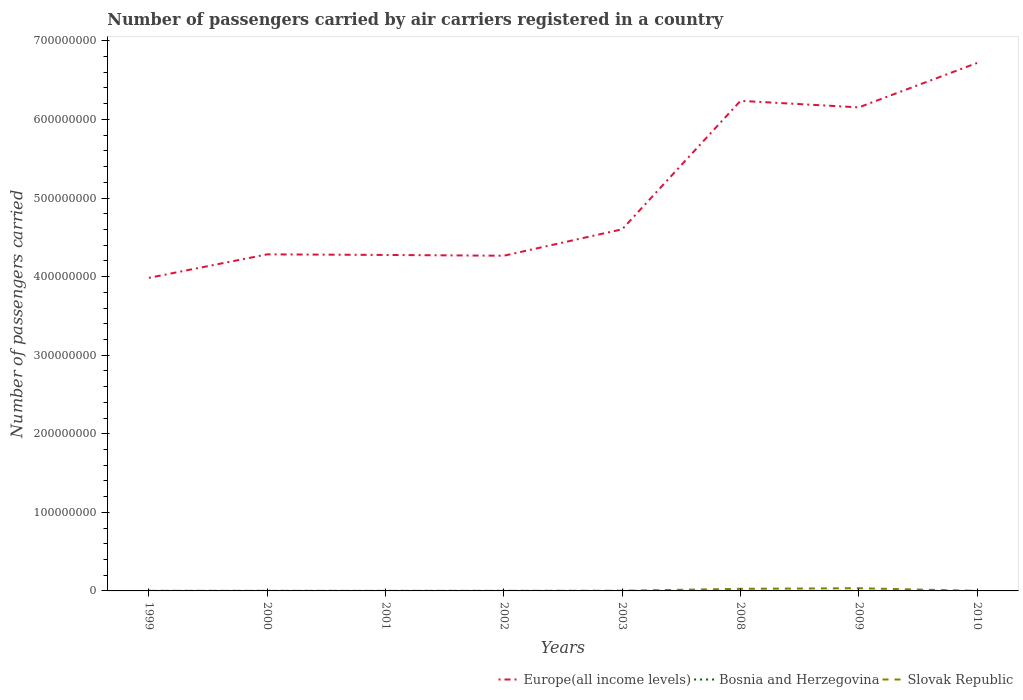How many different coloured lines are there?
Ensure brevity in your answer.  3. Across all years, what is the maximum number of passengers carried by air carriers in Europe(all income levels)?
Your response must be concise. 3.98e+08. What is the total number of passengers carried by air carriers in Bosnia and Herzegovina in the graph?
Give a very brief answer. 1.66e+04. What is the difference between the highest and the second highest number of passengers carried by air carriers in Slovak Republic?
Keep it short and to the point. 3.40e+06. How many lines are there?
Your response must be concise. 3. How many years are there in the graph?
Your answer should be compact. 8. What is the difference between two consecutive major ticks on the Y-axis?
Make the answer very short. 1.00e+08. Does the graph contain grids?
Your answer should be very brief. No. How many legend labels are there?
Offer a very short reply. 3. How are the legend labels stacked?
Provide a short and direct response. Horizontal. What is the title of the graph?
Ensure brevity in your answer.  Number of passengers carried by air carriers registered in a country. Does "Cambodia" appear as one of the legend labels in the graph?
Offer a very short reply. No. What is the label or title of the Y-axis?
Offer a very short reply. Number of passengers carried. What is the Number of passengers carried in Europe(all income levels) in 1999?
Your answer should be very brief. 3.98e+08. What is the Number of passengers carried of Bosnia and Herzegovina in 1999?
Ensure brevity in your answer.  6.01e+04. What is the Number of passengers carried of Slovak Republic in 1999?
Offer a very short reply. 1.11e+05. What is the Number of passengers carried in Europe(all income levels) in 2000?
Provide a succinct answer. 4.28e+08. What is the Number of passengers carried of Bosnia and Herzegovina in 2000?
Provide a succinct answer. 6.91e+04. What is the Number of passengers carried of Slovak Republic in 2000?
Offer a very short reply. 5.71e+04. What is the Number of passengers carried of Europe(all income levels) in 2001?
Your response must be concise. 4.28e+08. What is the Number of passengers carried in Bosnia and Herzegovina in 2001?
Make the answer very short. 6.50e+04. What is the Number of passengers carried in Slovak Republic in 2001?
Make the answer very short. 4.31e+04. What is the Number of passengers carried of Europe(all income levels) in 2002?
Keep it short and to the point. 4.27e+08. What is the Number of passengers carried of Bosnia and Herzegovina in 2002?
Give a very brief answer. 6.56e+04. What is the Number of passengers carried of Slovak Republic in 2002?
Keep it short and to the point. 8.28e+04. What is the Number of passengers carried of Europe(all income levels) in 2003?
Provide a succinct answer. 4.60e+08. What is the Number of passengers carried of Bosnia and Herzegovina in 2003?
Offer a terse response. 7.29e+04. What is the Number of passengers carried of Slovak Republic in 2003?
Offer a very short reply. 1.90e+05. What is the Number of passengers carried of Europe(all income levels) in 2008?
Offer a very short reply. 6.24e+08. What is the Number of passengers carried of Bosnia and Herzegovina in 2008?
Offer a terse response. 5.63e+04. What is the Number of passengers carried in Slovak Republic in 2008?
Offer a terse response. 2.69e+06. What is the Number of passengers carried in Europe(all income levels) in 2009?
Give a very brief answer. 6.15e+08. What is the Number of passengers carried in Bosnia and Herzegovina in 2009?
Provide a short and direct response. 8.00e+04. What is the Number of passengers carried in Slovak Republic in 2009?
Provide a succinct answer. 3.44e+06. What is the Number of passengers carried in Europe(all income levels) in 2010?
Your answer should be very brief. 6.72e+08. What is the Number of passengers carried in Bosnia and Herzegovina in 2010?
Make the answer very short. 5.65e+04. What is the Number of passengers carried in Slovak Republic in 2010?
Offer a very short reply. 7.49e+04. Across all years, what is the maximum Number of passengers carried in Europe(all income levels)?
Provide a short and direct response. 6.72e+08. Across all years, what is the maximum Number of passengers carried of Bosnia and Herzegovina?
Offer a very short reply. 8.00e+04. Across all years, what is the maximum Number of passengers carried in Slovak Republic?
Provide a short and direct response. 3.44e+06. Across all years, what is the minimum Number of passengers carried in Europe(all income levels)?
Provide a short and direct response. 3.98e+08. Across all years, what is the minimum Number of passengers carried of Bosnia and Herzegovina?
Give a very brief answer. 5.63e+04. Across all years, what is the minimum Number of passengers carried of Slovak Republic?
Offer a terse response. 4.31e+04. What is the total Number of passengers carried in Europe(all income levels) in the graph?
Provide a short and direct response. 4.05e+09. What is the total Number of passengers carried in Bosnia and Herzegovina in the graph?
Keep it short and to the point. 5.26e+05. What is the total Number of passengers carried in Slovak Republic in the graph?
Ensure brevity in your answer.  6.69e+06. What is the difference between the Number of passengers carried of Europe(all income levels) in 1999 and that in 2000?
Your answer should be compact. -2.99e+07. What is the difference between the Number of passengers carried in Bosnia and Herzegovina in 1999 and that in 2000?
Your response must be concise. -9042. What is the difference between the Number of passengers carried in Slovak Republic in 1999 and that in 2000?
Offer a terse response. 5.35e+04. What is the difference between the Number of passengers carried in Europe(all income levels) in 1999 and that in 2001?
Your response must be concise. -2.92e+07. What is the difference between the Number of passengers carried of Bosnia and Herzegovina in 1999 and that in 2001?
Provide a short and direct response. -4893. What is the difference between the Number of passengers carried in Slovak Republic in 1999 and that in 2001?
Make the answer very short. 6.75e+04. What is the difference between the Number of passengers carried of Europe(all income levels) in 1999 and that in 2002?
Your answer should be compact. -2.82e+07. What is the difference between the Number of passengers carried of Bosnia and Herzegovina in 1999 and that in 2002?
Keep it short and to the point. -5543. What is the difference between the Number of passengers carried in Slovak Republic in 1999 and that in 2002?
Make the answer very short. 2.78e+04. What is the difference between the Number of passengers carried of Europe(all income levels) in 1999 and that in 2003?
Your answer should be very brief. -6.18e+07. What is the difference between the Number of passengers carried in Bosnia and Herzegovina in 1999 and that in 2003?
Your response must be concise. -1.28e+04. What is the difference between the Number of passengers carried of Slovak Republic in 1999 and that in 2003?
Your response must be concise. -7.96e+04. What is the difference between the Number of passengers carried in Europe(all income levels) in 1999 and that in 2008?
Provide a succinct answer. -2.25e+08. What is the difference between the Number of passengers carried in Bosnia and Herzegovina in 1999 and that in 2008?
Ensure brevity in your answer.  3787. What is the difference between the Number of passengers carried of Slovak Republic in 1999 and that in 2008?
Offer a very short reply. -2.58e+06. What is the difference between the Number of passengers carried in Europe(all income levels) in 1999 and that in 2009?
Your answer should be very brief. -2.17e+08. What is the difference between the Number of passengers carried of Bosnia and Herzegovina in 1999 and that in 2009?
Keep it short and to the point. -1.99e+04. What is the difference between the Number of passengers carried in Slovak Republic in 1999 and that in 2009?
Keep it short and to the point. -3.33e+06. What is the difference between the Number of passengers carried in Europe(all income levels) in 1999 and that in 2010?
Offer a terse response. -2.73e+08. What is the difference between the Number of passengers carried in Bosnia and Herzegovina in 1999 and that in 2010?
Your answer should be very brief. 3614.84. What is the difference between the Number of passengers carried in Slovak Republic in 1999 and that in 2010?
Ensure brevity in your answer.  3.57e+04. What is the difference between the Number of passengers carried of Europe(all income levels) in 2000 and that in 2001?
Keep it short and to the point. 7.61e+05. What is the difference between the Number of passengers carried of Bosnia and Herzegovina in 2000 and that in 2001?
Keep it short and to the point. 4149. What is the difference between the Number of passengers carried in Slovak Republic in 2000 and that in 2001?
Offer a terse response. 1.40e+04. What is the difference between the Number of passengers carried in Europe(all income levels) in 2000 and that in 2002?
Ensure brevity in your answer.  1.76e+06. What is the difference between the Number of passengers carried of Bosnia and Herzegovina in 2000 and that in 2002?
Keep it short and to the point. 3499. What is the difference between the Number of passengers carried in Slovak Republic in 2000 and that in 2002?
Your answer should be very brief. -2.57e+04. What is the difference between the Number of passengers carried of Europe(all income levels) in 2000 and that in 2003?
Make the answer very short. -3.19e+07. What is the difference between the Number of passengers carried of Bosnia and Herzegovina in 2000 and that in 2003?
Your answer should be compact. -3722. What is the difference between the Number of passengers carried in Slovak Republic in 2000 and that in 2003?
Offer a terse response. -1.33e+05. What is the difference between the Number of passengers carried of Europe(all income levels) in 2000 and that in 2008?
Provide a succinct answer. -1.95e+08. What is the difference between the Number of passengers carried of Bosnia and Herzegovina in 2000 and that in 2008?
Provide a short and direct response. 1.28e+04. What is the difference between the Number of passengers carried in Slovak Republic in 2000 and that in 2008?
Make the answer very short. -2.63e+06. What is the difference between the Number of passengers carried in Europe(all income levels) in 2000 and that in 2009?
Offer a very short reply. -1.87e+08. What is the difference between the Number of passengers carried of Bosnia and Herzegovina in 2000 and that in 2009?
Offer a very short reply. -1.08e+04. What is the difference between the Number of passengers carried in Slovak Republic in 2000 and that in 2009?
Provide a succinct answer. -3.38e+06. What is the difference between the Number of passengers carried of Europe(all income levels) in 2000 and that in 2010?
Your answer should be very brief. -2.44e+08. What is the difference between the Number of passengers carried in Bosnia and Herzegovina in 2000 and that in 2010?
Your response must be concise. 1.27e+04. What is the difference between the Number of passengers carried of Slovak Republic in 2000 and that in 2010?
Offer a very short reply. -1.78e+04. What is the difference between the Number of passengers carried of Europe(all income levels) in 2001 and that in 2002?
Make the answer very short. 9.99e+05. What is the difference between the Number of passengers carried of Bosnia and Herzegovina in 2001 and that in 2002?
Offer a very short reply. -650. What is the difference between the Number of passengers carried in Slovak Republic in 2001 and that in 2002?
Your response must be concise. -3.97e+04. What is the difference between the Number of passengers carried of Europe(all income levels) in 2001 and that in 2003?
Ensure brevity in your answer.  -3.26e+07. What is the difference between the Number of passengers carried in Bosnia and Herzegovina in 2001 and that in 2003?
Make the answer very short. -7871. What is the difference between the Number of passengers carried of Slovak Republic in 2001 and that in 2003?
Your answer should be compact. -1.47e+05. What is the difference between the Number of passengers carried of Europe(all income levels) in 2001 and that in 2008?
Make the answer very short. -1.96e+08. What is the difference between the Number of passengers carried of Bosnia and Herzegovina in 2001 and that in 2008?
Give a very brief answer. 8680. What is the difference between the Number of passengers carried in Slovak Republic in 2001 and that in 2008?
Offer a terse response. -2.65e+06. What is the difference between the Number of passengers carried in Europe(all income levels) in 2001 and that in 2009?
Ensure brevity in your answer.  -1.88e+08. What is the difference between the Number of passengers carried in Bosnia and Herzegovina in 2001 and that in 2009?
Provide a succinct answer. -1.50e+04. What is the difference between the Number of passengers carried of Slovak Republic in 2001 and that in 2009?
Keep it short and to the point. -3.40e+06. What is the difference between the Number of passengers carried in Europe(all income levels) in 2001 and that in 2010?
Ensure brevity in your answer.  -2.44e+08. What is the difference between the Number of passengers carried of Bosnia and Herzegovina in 2001 and that in 2010?
Your answer should be compact. 8507.84. What is the difference between the Number of passengers carried of Slovak Republic in 2001 and that in 2010?
Provide a succinct answer. -3.17e+04. What is the difference between the Number of passengers carried in Europe(all income levels) in 2002 and that in 2003?
Give a very brief answer. -3.36e+07. What is the difference between the Number of passengers carried in Bosnia and Herzegovina in 2002 and that in 2003?
Make the answer very short. -7221. What is the difference between the Number of passengers carried of Slovak Republic in 2002 and that in 2003?
Provide a short and direct response. -1.07e+05. What is the difference between the Number of passengers carried in Europe(all income levels) in 2002 and that in 2008?
Give a very brief answer. -1.97e+08. What is the difference between the Number of passengers carried of Bosnia and Herzegovina in 2002 and that in 2008?
Your answer should be compact. 9330. What is the difference between the Number of passengers carried of Slovak Republic in 2002 and that in 2008?
Keep it short and to the point. -2.61e+06. What is the difference between the Number of passengers carried of Europe(all income levels) in 2002 and that in 2009?
Your answer should be compact. -1.89e+08. What is the difference between the Number of passengers carried of Bosnia and Herzegovina in 2002 and that in 2009?
Make the answer very short. -1.43e+04. What is the difference between the Number of passengers carried in Slovak Republic in 2002 and that in 2009?
Offer a terse response. -3.36e+06. What is the difference between the Number of passengers carried in Europe(all income levels) in 2002 and that in 2010?
Provide a short and direct response. -2.45e+08. What is the difference between the Number of passengers carried of Bosnia and Herzegovina in 2002 and that in 2010?
Provide a short and direct response. 9157.84. What is the difference between the Number of passengers carried in Slovak Republic in 2002 and that in 2010?
Offer a very short reply. 7965. What is the difference between the Number of passengers carried of Europe(all income levels) in 2003 and that in 2008?
Ensure brevity in your answer.  -1.63e+08. What is the difference between the Number of passengers carried of Bosnia and Herzegovina in 2003 and that in 2008?
Ensure brevity in your answer.  1.66e+04. What is the difference between the Number of passengers carried of Slovak Republic in 2003 and that in 2008?
Offer a terse response. -2.50e+06. What is the difference between the Number of passengers carried in Europe(all income levels) in 2003 and that in 2009?
Offer a very short reply. -1.55e+08. What is the difference between the Number of passengers carried in Bosnia and Herzegovina in 2003 and that in 2009?
Make the answer very short. -7113. What is the difference between the Number of passengers carried of Slovak Republic in 2003 and that in 2009?
Give a very brief answer. -3.25e+06. What is the difference between the Number of passengers carried in Europe(all income levels) in 2003 and that in 2010?
Give a very brief answer. -2.12e+08. What is the difference between the Number of passengers carried in Bosnia and Herzegovina in 2003 and that in 2010?
Offer a very short reply. 1.64e+04. What is the difference between the Number of passengers carried of Slovak Republic in 2003 and that in 2010?
Give a very brief answer. 1.15e+05. What is the difference between the Number of passengers carried of Europe(all income levels) in 2008 and that in 2009?
Your response must be concise. 8.29e+06. What is the difference between the Number of passengers carried in Bosnia and Herzegovina in 2008 and that in 2009?
Offer a very short reply. -2.37e+04. What is the difference between the Number of passengers carried in Slovak Republic in 2008 and that in 2009?
Your answer should be very brief. -7.50e+05. What is the difference between the Number of passengers carried of Europe(all income levels) in 2008 and that in 2010?
Provide a succinct answer. -4.82e+07. What is the difference between the Number of passengers carried in Bosnia and Herzegovina in 2008 and that in 2010?
Make the answer very short. -172.16. What is the difference between the Number of passengers carried in Slovak Republic in 2008 and that in 2010?
Offer a very short reply. 2.62e+06. What is the difference between the Number of passengers carried of Europe(all income levels) in 2009 and that in 2010?
Keep it short and to the point. -5.65e+07. What is the difference between the Number of passengers carried in Bosnia and Herzegovina in 2009 and that in 2010?
Your answer should be very brief. 2.35e+04. What is the difference between the Number of passengers carried in Slovak Republic in 2009 and that in 2010?
Make the answer very short. 3.37e+06. What is the difference between the Number of passengers carried of Europe(all income levels) in 1999 and the Number of passengers carried of Bosnia and Herzegovina in 2000?
Keep it short and to the point. 3.98e+08. What is the difference between the Number of passengers carried of Europe(all income levels) in 1999 and the Number of passengers carried of Slovak Republic in 2000?
Give a very brief answer. 3.98e+08. What is the difference between the Number of passengers carried of Bosnia and Herzegovina in 1999 and the Number of passengers carried of Slovak Republic in 2000?
Make the answer very short. 3005. What is the difference between the Number of passengers carried in Europe(all income levels) in 1999 and the Number of passengers carried in Bosnia and Herzegovina in 2001?
Make the answer very short. 3.98e+08. What is the difference between the Number of passengers carried of Europe(all income levels) in 1999 and the Number of passengers carried of Slovak Republic in 2001?
Your response must be concise. 3.98e+08. What is the difference between the Number of passengers carried of Bosnia and Herzegovina in 1999 and the Number of passengers carried of Slovak Republic in 2001?
Keep it short and to the point. 1.70e+04. What is the difference between the Number of passengers carried in Europe(all income levels) in 1999 and the Number of passengers carried in Bosnia and Herzegovina in 2002?
Offer a terse response. 3.98e+08. What is the difference between the Number of passengers carried in Europe(all income levels) in 1999 and the Number of passengers carried in Slovak Republic in 2002?
Offer a terse response. 3.98e+08. What is the difference between the Number of passengers carried in Bosnia and Herzegovina in 1999 and the Number of passengers carried in Slovak Republic in 2002?
Keep it short and to the point. -2.27e+04. What is the difference between the Number of passengers carried of Europe(all income levels) in 1999 and the Number of passengers carried of Bosnia and Herzegovina in 2003?
Ensure brevity in your answer.  3.98e+08. What is the difference between the Number of passengers carried in Europe(all income levels) in 1999 and the Number of passengers carried in Slovak Republic in 2003?
Give a very brief answer. 3.98e+08. What is the difference between the Number of passengers carried in Bosnia and Herzegovina in 1999 and the Number of passengers carried in Slovak Republic in 2003?
Your response must be concise. -1.30e+05. What is the difference between the Number of passengers carried of Europe(all income levels) in 1999 and the Number of passengers carried of Bosnia and Herzegovina in 2008?
Ensure brevity in your answer.  3.98e+08. What is the difference between the Number of passengers carried in Europe(all income levels) in 1999 and the Number of passengers carried in Slovak Republic in 2008?
Provide a short and direct response. 3.96e+08. What is the difference between the Number of passengers carried in Bosnia and Herzegovina in 1999 and the Number of passengers carried in Slovak Republic in 2008?
Make the answer very short. -2.63e+06. What is the difference between the Number of passengers carried in Europe(all income levels) in 1999 and the Number of passengers carried in Bosnia and Herzegovina in 2009?
Your answer should be compact. 3.98e+08. What is the difference between the Number of passengers carried of Europe(all income levels) in 1999 and the Number of passengers carried of Slovak Republic in 2009?
Your response must be concise. 3.95e+08. What is the difference between the Number of passengers carried in Bosnia and Herzegovina in 1999 and the Number of passengers carried in Slovak Republic in 2009?
Your response must be concise. -3.38e+06. What is the difference between the Number of passengers carried in Europe(all income levels) in 1999 and the Number of passengers carried in Bosnia and Herzegovina in 2010?
Keep it short and to the point. 3.98e+08. What is the difference between the Number of passengers carried in Europe(all income levels) in 1999 and the Number of passengers carried in Slovak Republic in 2010?
Provide a short and direct response. 3.98e+08. What is the difference between the Number of passengers carried in Bosnia and Herzegovina in 1999 and the Number of passengers carried in Slovak Republic in 2010?
Your answer should be very brief. -1.48e+04. What is the difference between the Number of passengers carried in Europe(all income levels) in 2000 and the Number of passengers carried in Bosnia and Herzegovina in 2001?
Your answer should be very brief. 4.28e+08. What is the difference between the Number of passengers carried in Europe(all income levels) in 2000 and the Number of passengers carried in Slovak Republic in 2001?
Your response must be concise. 4.28e+08. What is the difference between the Number of passengers carried in Bosnia and Herzegovina in 2000 and the Number of passengers carried in Slovak Republic in 2001?
Provide a succinct answer. 2.60e+04. What is the difference between the Number of passengers carried of Europe(all income levels) in 2000 and the Number of passengers carried of Bosnia and Herzegovina in 2002?
Give a very brief answer. 4.28e+08. What is the difference between the Number of passengers carried in Europe(all income levels) in 2000 and the Number of passengers carried in Slovak Republic in 2002?
Your answer should be compact. 4.28e+08. What is the difference between the Number of passengers carried in Bosnia and Herzegovina in 2000 and the Number of passengers carried in Slovak Republic in 2002?
Provide a short and direct response. -1.37e+04. What is the difference between the Number of passengers carried in Europe(all income levels) in 2000 and the Number of passengers carried in Bosnia and Herzegovina in 2003?
Your answer should be very brief. 4.28e+08. What is the difference between the Number of passengers carried in Europe(all income levels) in 2000 and the Number of passengers carried in Slovak Republic in 2003?
Offer a very short reply. 4.28e+08. What is the difference between the Number of passengers carried in Bosnia and Herzegovina in 2000 and the Number of passengers carried in Slovak Republic in 2003?
Your response must be concise. -1.21e+05. What is the difference between the Number of passengers carried of Europe(all income levels) in 2000 and the Number of passengers carried of Bosnia and Herzegovina in 2008?
Provide a succinct answer. 4.28e+08. What is the difference between the Number of passengers carried of Europe(all income levels) in 2000 and the Number of passengers carried of Slovak Republic in 2008?
Make the answer very short. 4.26e+08. What is the difference between the Number of passengers carried of Bosnia and Herzegovina in 2000 and the Number of passengers carried of Slovak Republic in 2008?
Keep it short and to the point. -2.62e+06. What is the difference between the Number of passengers carried in Europe(all income levels) in 2000 and the Number of passengers carried in Bosnia and Herzegovina in 2009?
Keep it short and to the point. 4.28e+08. What is the difference between the Number of passengers carried of Europe(all income levels) in 2000 and the Number of passengers carried of Slovak Republic in 2009?
Provide a short and direct response. 4.25e+08. What is the difference between the Number of passengers carried of Bosnia and Herzegovina in 2000 and the Number of passengers carried of Slovak Republic in 2009?
Your answer should be compact. -3.37e+06. What is the difference between the Number of passengers carried of Europe(all income levels) in 2000 and the Number of passengers carried of Bosnia and Herzegovina in 2010?
Keep it short and to the point. 4.28e+08. What is the difference between the Number of passengers carried of Europe(all income levels) in 2000 and the Number of passengers carried of Slovak Republic in 2010?
Keep it short and to the point. 4.28e+08. What is the difference between the Number of passengers carried in Bosnia and Herzegovina in 2000 and the Number of passengers carried in Slovak Republic in 2010?
Give a very brief answer. -5714. What is the difference between the Number of passengers carried in Europe(all income levels) in 2001 and the Number of passengers carried in Bosnia and Herzegovina in 2002?
Provide a short and direct response. 4.27e+08. What is the difference between the Number of passengers carried in Europe(all income levels) in 2001 and the Number of passengers carried in Slovak Republic in 2002?
Your answer should be very brief. 4.27e+08. What is the difference between the Number of passengers carried of Bosnia and Herzegovina in 2001 and the Number of passengers carried of Slovak Republic in 2002?
Provide a short and direct response. -1.78e+04. What is the difference between the Number of passengers carried of Europe(all income levels) in 2001 and the Number of passengers carried of Bosnia and Herzegovina in 2003?
Offer a terse response. 4.27e+08. What is the difference between the Number of passengers carried of Europe(all income levels) in 2001 and the Number of passengers carried of Slovak Republic in 2003?
Provide a succinct answer. 4.27e+08. What is the difference between the Number of passengers carried of Bosnia and Herzegovina in 2001 and the Number of passengers carried of Slovak Republic in 2003?
Give a very brief answer. -1.25e+05. What is the difference between the Number of passengers carried of Europe(all income levels) in 2001 and the Number of passengers carried of Bosnia and Herzegovina in 2008?
Ensure brevity in your answer.  4.27e+08. What is the difference between the Number of passengers carried of Europe(all income levels) in 2001 and the Number of passengers carried of Slovak Republic in 2008?
Your response must be concise. 4.25e+08. What is the difference between the Number of passengers carried of Bosnia and Herzegovina in 2001 and the Number of passengers carried of Slovak Republic in 2008?
Your response must be concise. -2.63e+06. What is the difference between the Number of passengers carried in Europe(all income levels) in 2001 and the Number of passengers carried in Bosnia and Herzegovina in 2009?
Ensure brevity in your answer.  4.27e+08. What is the difference between the Number of passengers carried in Europe(all income levels) in 2001 and the Number of passengers carried in Slovak Republic in 2009?
Keep it short and to the point. 4.24e+08. What is the difference between the Number of passengers carried of Bosnia and Herzegovina in 2001 and the Number of passengers carried of Slovak Republic in 2009?
Your response must be concise. -3.38e+06. What is the difference between the Number of passengers carried in Europe(all income levels) in 2001 and the Number of passengers carried in Bosnia and Herzegovina in 2010?
Provide a succinct answer. 4.27e+08. What is the difference between the Number of passengers carried in Europe(all income levels) in 2001 and the Number of passengers carried in Slovak Republic in 2010?
Provide a succinct answer. 4.27e+08. What is the difference between the Number of passengers carried of Bosnia and Herzegovina in 2001 and the Number of passengers carried of Slovak Republic in 2010?
Give a very brief answer. -9863. What is the difference between the Number of passengers carried of Europe(all income levels) in 2002 and the Number of passengers carried of Bosnia and Herzegovina in 2003?
Ensure brevity in your answer.  4.26e+08. What is the difference between the Number of passengers carried of Europe(all income levels) in 2002 and the Number of passengers carried of Slovak Republic in 2003?
Offer a terse response. 4.26e+08. What is the difference between the Number of passengers carried of Bosnia and Herzegovina in 2002 and the Number of passengers carried of Slovak Republic in 2003?
Ensure brevity in your answer.  -1.25e+05. What is the difference between the Number of passengers carried in Europe(all income levels) in 2002 and the Number of passengers carried in Bosnia and Herzegovina in 2008?
Offer a very short reply. 4.26e+08. What is the difference between the Number of passengers carried of Europe(all income levels) in 2002 and the Number of passengers carried of Slovak Republic in 2008?
Your answer should be compact. 4.24e+08. What is the difference between the Number of passengers carried in Bosnia and Herzegovina in 2002 and the Number of passengers carried in Slovak Republic in 2008?
Ensure brevity in your answer.  -2.62e+06. What is the difference between the Number of passengers carried of Europe(all income levels) in 2002 and the Number of passengers carried of Bosnia and Herzegovina in 2009?
Offer a very short reply. 4.26e+08. What is the difference between the Number of passengers carried in Europe(all income levels) in 2002 and the Number of passengers carried in Slovak Republic in 2009?
Offer a very short reply. 4.23e+08. What is the difference between the Number of passengers carried of Bosnia and Herzegovina in 2002 and the Number of passengers carried of Slovak Republic in 2009?
Offer a very short reply. -3.38e+06. What is the difference between the Number of passengers carried of Europe(all income levels) in 2002 and the Number of passengers carried of Bosnia and Herzegovina in 2010?
Make the answer very short. 4.26e+08. What is the difference between the Number of passengers carried in Europe(all income levels) in 2002 and the Number of passengers carried in Slovak Republic in 2010?
Your response must be concise. 4.26e+08. What is the difference between the Number of passengers carried of Bosnia and Herzegovina in 2002 and the Number of passengers carried of Slovak Republic in 2010?
Make the answer very short. -9213. What is the difference between the Number of passengers carried in Europe(all income levels) in 2003 and the Number of passengers carried in Bosnia and Herzegovina in 2008?
Your answer should be very brief. 4.60e+08. What is the difference between the Number of passengers carried in Europe(all income levels) in 2003 and the Number of passengers carried in Slovak Republic in 2008?
Provide a short and direct response. 4.58e+08. What is the difference between the Number of passengers carried in Bosnia and Herzegovina in 2003 and the Number of passengers carried in Slovak Republic in 2008?
Provide a short and direct response. -2.62e+06. What is the difference between the Number of passengers carried in Europe(all income levels) in 2003 and the Number of passengers carried in Bosnia and Herzegovina in 2009?
Your answer should be very brief. 4.60e+08. What is the difference between the Number of passengers carried of Europe(all income levels) in 2003 and the Number of passengers carried of Slovak Republic in 2009?
Ensure brevity in your answer.  4.57e+08. What is the difference between the Number of passengers carried of Bosnia and Herzegovina in 2003 and the Number of passengers carried of Slovak Republic in 2009?
Offer a very short reply. -3.37e+06. What is the difference between the Number of passengers carried in Europe(all income levels) in 2003 and the Number of passengers carried in Bosnia and Herzegovina in 2010?
Keep it short and to the point. 4.60e+08. What is the difference between the Number of passengers carried in Europe(all income levels) in 2003 and the Number of passengers carried in Slovak Republic in 2010?
Your answer should be very brief. 4.60e+08. What is the difference between the Number of passengers carried of Bosnia and Herzegovina in 2003 and the Number of passengers carried of Slovak Republic in 2010?
Your answer should be very brief. -1992. What is the difference between the Number of passengers carried in Europe(all income levels) in 2008 and the Number of passengers carried in Bosnia and Herzegovina in 2009?
Offer a terse response. 6.24e+08. What is the difference between the Number of passengers carried of Europe(all income levels) in 2008 and the Number of passengers carried of Slovak Republic in 2009?
Your answer should be very brief. 6.20e+08. What is the difference between the Number of passengers carried in Bosnia and Herzegovina in 2008 and the Number of passengers carried in Slovak Republic in 2009?
Provide a succinct answer. -3.38e+06. What is the difference between the Number of passengers carried of Europe(all income levels) in 2008 and the Number of passengers carried of Bosnia and Herzegovina in 2010?
Your response must be concise. 6.24e+08. What is the difference between the Number of passengers carried of Europe(all income levels) in 2008 and the Number of passengers carried of Slovak Republic in 2010?
Keep it short and to the point. 6.24e+08. What is the difference between the Number of passengers carried in Bosnia and Herzegovina in 2008 and the Number of passengers carried in Slovak Republic in 2010?
Your answer should be compact. -1.85e+04. What is the difference between the Number of passengers carried in Europe(all income levels) in 2009 and the Number of passengers carried in Bosnia and Herzegovina in 2010?
Your response must be concise. 6.15e+08. What is the difference between the Number of passengers carried in Europe(all income levels) in 2009 and the Number of passengers carried in Slovak Republic in 2010?
Your response must be concise. 6.15e+08. What is the difference between the Number of passengers carried of Bosnia and Herzegovina in 2009 and the Number of passengers carried of Slovak Republic in 2010?
Give a very brief answer. 5121. What is the average Number of passengers carried of Europe(all income levels) per year?
Provide a succinct answer. 5.06e+08. What is the average Number of passengers carried in Bosnia and Herzegovina per year?
Your response must be concise. 6.57e+04. What is the average Number of passengers carried in Slovak Republic per year?
Offer a terse response. 8.36e+05. In the year 1999, what is the difference between the Number of passengers carried of Europe(all income levels) and Number of passengers carried of Bosnia and Herzegovina?
Your answer should be compact. 3.98e+08. In the year 1999, what is the difference between the Number of passengers carried of Europe(all income levels) and Number of passengers carried of Slovak Republic?
Offer a very short reply. 3.98e+08. In the year 1999, what is the difference between the Number of passengers carried of Bosnia and Herzegovina and Number of passengers carried of Slovak Republic?
Make the answer very short. -5.05e+04. In the year 2000, what is the difference between the Number of passengers carried in Europe(all income levels) and Number of passengers carried in Bosnia and Herzegovina?
Provide a short and direct response. 4.28e+08. In the year 2000, what is the difference between the Number of passengers carried in Europe(all income levels) and Number of passengers carried in Slovak Republic?
Give a very brief answer. 4.28e+08. In the year 2000, what is the difference between the Number of passengers carried of Bosnia and Herzegovina and Number of passengers carried of Slovak Republic?
Provide a short and direct response. 1.20e+04. In the year 2001, what is the difference between the Number of passengers carried of Europe(all income levels) and Number of passengers carried of Bosnia and Herzegovina?
Your answer should be compact. 4.27e+08. In the year 2001, what is the difference between the Number of passengers carried in Europe(all income levels) and Number of passengers carried in Slovak Republic?
Provide a succinct answer. 4.28e+08. In the year 2001, what is the difference between the Number of passengers carried in Bosnia and Herzegovina and Number of passengers carried in Slovak Republic?
Your answer should be compact. 2.19e+04. In the year 2002, what is the difference between the Number of passengers carried in Europe(all income levels) and Number of passengers carried in Bosnia and Herzegovina?
Give a very brief answer. 4.26e+08. In the year 2002, what is the difference between the Number of passengers carried of Europe(all income levels) and Number of passengers carried of Slovak Republic?
Make the answer very short. 4.26e+08. In the year 2002, what is the difference between the Number of passengers carried of Bosnia and Herzegovina and Number of passengers carried of Slovak Republic?
Offer a very short reply. -1.72e+04. In the year 2003, what is the difference between the Number of passengers carried in Europe(all income levels) and Number of passengers carried in Bosnia and Herzegovina?
Your answer should be compact. 4.60e+08. In the year 2003, what is the difference between the Number of passengers carried in Europe(all income levels) and Number of passengers carried in Slovak Republic?
Provide a short and direct response. 4.60e+08. In the year 2003, what is the difference between the Number of passengers carried in Bosnia and Herzegovina and Number of passengers carried in Slovak Republic?
Keep it short and to the point. -1.17e+05. In the year 2008, what is the difference between the Number of passengers carried of Europe(all income levels) and Number of passengers carried of Bosnia and Herzegovina?
Offer a terse response. 6.24e+08. In the year 2008, what is the difference between the Number of passengers carried in Europe(all income levels) and Number of passengers carried in Slovak Republic?
Offer a very short reply. 6.21e+08. In the year 2008, what is the difference between the Number of passengers carried in Bosnia and Herzegovina and Number of passengers carried in Slovak Republic?
Ensure brevity in your answer.  -2.63e+06. In the year 2009, what is the difference between the Number of passengers carried in Europe(all income levels) and Number of passengers carried in Bosnia and Herzegovina?
Ensure brevity in your answer.  6.15e+08. In the year 2009, what is the difference between the Number of passengers carried of Europe(all income levels) and Number of passengers carried of Slovak Republic?
Provide a short and direct response. 6.12e+08. In the year 2009, what is the difference between the Number of passengers carried of Bosnia and Herzegovina and Number of passengers carried of Slovak Republic?
Offer a terse response. -3.36e+06. In the year 2010, what is the difference between the Number of passengers carried in Europe(all income levels) and Number of passengers carried in Bosnia and Herzegovina?
Ensure brevity in your answer.  6.72e+08. In the year 2010, what is the difference between the Number of passengers carried of Europe(all income levels) and Number of passengers carried of Slovak Republic?
Your response must be concise. 6.72e+08. In the year 2010, what is the difference between the Number of passengers carried of Bosnia and Herzegovina and Number of passengers carried of Slovak Republic?
Provide a short and direct response. -1.84e+04. What is the ratio of the Number of passengers carried in Europe(all income levels) in 1999 to that in 2000?
Provide a short and direct response. 0.93. What is the ratio of the Number of passengers carried of Bosnia and Herzegovina in 1999 to that in 2000?
Your answer should be compact. 0.87. What is the ratio of the Number of passengers carried of Slovak Republic in 1999 to that in 2000?
Your response must be concise. 1.94. What is the ratio of the Number of passengers carried in Europe(all income levels) in 1999 to that in 2001?
Your answer should be compact. 0.93. What is the ratio of the Number of passengers carried of Bosnia and Herzegovina in 1999 to that in 2001?
Your answer should be compact. 0.92. What is the ratio of the Number of passengers carried of Slovak Republic in 1999 to that in 2001?
Ensure brevity in your answer.  2.57. What is the ratio of the Number of passengers carried in Europe(all income levels) in 1999 to that in 2002?
Ensure brevity in your answer.  0.93. What is the ratio of the Number of passengers carried of Bosnia and Herzegovina in 1999 to that in 2002?
Your response must be concise. 0.92. What is the ratio of the Number of passengers carried of Slovak Republic in 1999 to that in 2002?
Give a very brief answer. 1.34. What is the ratio of the Number of passengers carried in Europe(all income levels) in 1999 to that in 2003?
Provide a short and direct response. 0.87. What is the ratio of the Number of passengers carried of Bosnia and Herzegovina in 1999 to that in 2003?
Ensure brevity in your answer.  0.82. What is the ratio of the Number of passengers carried in Slovak Republic in 1999 to that in 2003?
Your answer should be compact. 0.58. What is the ratio of the Number of passengers carried in Europe(all income levels) in 1999 to that in 2008?
Your answer should be very brief. 0.64. What is the ratio of the Number of passengers carried of Bosnia and Herzegovina in 1999 to that in 2008?
Your answer should be very brief. 1.07. What is the ratio of the Number of passengers carried of Slovak Republic in 1999 to that in 2008?
Ensure brevity in your answer.  0.04. What is the ratio of the Number of passengers carried in Europe(all income levels) in 1999 to that in 2009?
Your answer should be very brief. 0.65. What is the ratio of the Number of passengers carried of Bosnia and Herzegovina in 1999 to that in 2009?
Your answer should be compact. 0.75. What is the ratio of the Number of passengers carried in Slovak Republic in 1999 to that in 2009?
Provide a succinct answer. 0.03. What is the ratio of the Number of passengers carried of Europe(all income levels) in 1999 to that in 2010?
Your answer should be compact. 0.59. What is the ratio of the Number of passengers carried in Bosnia and Herzegovina in 1999 to that in 2010?
Your response must be concise. 1.06. What is the ratio of the Number of passengers carried of Slovak Republic in 1999 to that in 2010?
Make the answer very short. 1.48. What is the ratio of the Number of passengers carried in Bosnia and Herzegovina in 2000 to that in 2001?
Provide a succinct answer. 1.06. What is the ratio of the Number of passengers carried in Slovak Republic in 2000 to that in 2001?
Keep it short and to the point. 1.32. What is the ratio of the Number of passengers carried in Bosnia and Herzegovina in 2000 to that in 2002?
Provide a short and direct response. 1.05. What is the ratio of the Number of passengers carried in Slovak Republic in 2000 to that in 2002?
Your answer should be very brief. 0.69. What is the ratio of the Number of passengers carried of Europe(all income levels) in 2000 to that in 2003?
Provide a short and direct response. 0.93. What is the ratio of the Number of passengers carried of Bosnia and Herzegovina in 2000 to that in 2003?
Provide a succinct answer. 0.95. What is the ratio of the Number of passengers carried of Slovak Republic in 2000 to that in 2003?
Make the answer very short. 0.3. What is the ratio of the Number of passengers carried of Europe(all income levels) in 2000 to that in 2008?
Provide a succinct answer. 0.69. What is the ratio of the Number of passengers carried in Bosnia and Herzegovina in 2000 to that in 2008?
Keep it short and to the point. 1.23. What is the ratio of the Number of passengers carried of Slovak Republic in 2000 to that in 2008?
Your answer should be compact. 0.02. What is the ratio of the Number of passengers carried in Europe(all income levels) in 2000 to that in 2009?
Your answer should be very brief. 0.7. What is the ratio of the Number of passengers carried in Bosnia and Herzegovina in 2000 to that in 2009?
Keep it short and to the point. 0.86. What is the ratio of the Number of passengers carried of Slovak Republic in 2000 to that in 2009?
Your response must be concise. 0.02. What is the ratio of the Number of passengers carried in Europe(all income levels) in 2000 to that in 2010?
Offer a very short reply. 0.64. What is the ratio of the Number of passengers carried in Bosnia and Herzegovina in 2000 to that in 2010?
Provide a succinct answer. 1.22. What is the ratio of the Number of passengers carried in Slovak Republic in 2000 to that in 2010?
Give a very brief answer. 0.76. What is the ratio of the Number of passengers carried of Slovak Republic in 2001 to that in 2002?
Offer a terse response. 0.52. What is the ratio of the Number of passengers carried in Europe(all income levels) in 2001 to that in 2003?
Ensure brevity in your answer.  0.93. What is the ratio of the Number of passengers carried in Bosnia and Herzegovina in 2001 to that in 2003?
Offer a terse response. 0.89. What is the ratio of the Number of passengers carried in Slovak Republic in 2001 to that in 2003?
Offer a very short reply. 0.23. What is the ratio of the Number of passengers carried in Europe(all income levels) in 2001 to that in 2008?
Make the answer very short. 0.69. What is the ratio of the Number of passengers carried of Bosnia and Herzegovina in 2001 to that in 2008?
Offer a terse response. 1.15. What is the ratio of the Number of passengers carried in Slovak Republic in 2001 to that in 2008?
Your answer should be compact. 0.02. What is the ratio of the Number of passengers carried in Europe(all income levels) in 2001 to that in 2009?
Your answer should be very brief. 0.69. What is the ratio of the Number of passengers carried in Bosnia and Herzegovina in 2001 to that in 2009?
Keep it short and to the point. 0.81. What is the ratio of the Number of passengers carried of Slovak Republic in 2001 to that in 2009?
Provide a short and direct response. 0.01. What is the ratio of the Number of passengers carried in Europe(all income levels) in 2001 to that in 2010?
Give a very brief answer. 0.64. What is the ratio of the Number of passengers carried of Bosnia and Herzegovina in 2001 to that in 2010?
Provide a short and direct response. 1.15. What is the ratio of the Number of passengers carried in Slovak Republic in 2001 to that in 2010?
Provide a succinct answer. 0.58. What is the ratio of the Number of passengers carried in Europe(all income levels) in 2002 to that in 2003?
Your answer should be very brief. 0.93. What is the ratio of the Number of passengers carried of Bosnia and Herzegovina in 2002 to that in 2003?
Ensure brevity in your answer.  0.9. What is the ratio of the Number of passengers carried in Slovak Republic in 2002 to that in 2003?
Give a very brief answer. 0.44. What is the ratio of the Number of passengers carried of Europe(all income levels) in 2002 to that in 2008?
Your answer should be compact. 0.68. What is the ratio of the Number of passengers carried of Bosnia and Herzegovina in 2002 to that in 2008?
Your response must be concise. 1.17. What is the ratio of the Number of passengers carried in Slovak Republic in 2002 to that in 2008?
Provide a succinct answer. 0.03. What is the ratio of the Number of passengers carried in Europe(all income levels) in 2002 to that in 2009?
Your answer should be very brief. 0.69. What is the ratio of the Number of passengers carried of Bosnia and Herzegovina in 2002 to that in 2009?
Ensure brevity in your answer.  0.82. What is the ratio of the Number of passengers carried in Slovak Republic in 2002 to that in 2009?
Offer a terse response. 0.02. What is the ratio of the Number of passengers carried of Europe(all income levels) in 2002 to that in 2010?
Offer a terse response. 0.63. What is the ratio of the Number of passengers carried of Bosnia and Herzegovina in 2002 to that in 2010?
Make the answer very short. 1.16. What is the ratio of the Number of passengers carried in Slovak Republic in 2002 to that in 2010?
Your answer should be very brief. 1.11. What is the ratio of the Number of passengers carried in Europe(all income levels) in 2003 to that in 2008?
Provide a succinct answer. 0.74. What is the ratio of the Number of passengers carried in Bosnia and Herzegovina in 2003 to that in 2008?
Your answer should be very brief. 1.29. What is the ratio of the Number of passengers carried in Slovak Republic in 2003 to that in 2008?
Provide a short and direct response. 0.07. What is the ratio of the Number of passengers carried in Europe(all income levels) in 2003 to that in 2009?
Make the answer very short. 0.75. What is the ratio of the Number of passengers carried in Bosnia and Herzegovina in 2003 to that in 2009?
Your answer should be compact. 0.91. What is the ratio of the Number of passengers carried in Slovak Republic in 2003 to that in 2009?
Ensure brevity in your answer.  0.06. What is the ratio of the Number of passengers carried in Europe(all income levels) in 2003 to that in 2010?
Keep it short and to the point. 0.69. What is the ratio of the Number of passengers carried of Bosnia and Herzegovina in 2003 to that in 2010?
Your answer should be compact. 1.29. What is the ratio of the Number of passengers carried of Slovak Republic in 2003 to that in 2010?
Ensure brevity in your answer.  2.54. What is the ratio of the Number of passengers carried of Europe(all income levels) in 2008 to that in 2009?
Make the answer very short. 1.01. What is the ratio of the Number of passengers carried in Bosnia and Herzegovina in 2008 to that in 2009?
Offer a very short reply. 0.7. What is the ratio of the Number of passengers carried in Slovak Republic in 2008 to that in 2009?
Your answer should be compact. 0.78. What is the ratio of the Number of passengers carried in Europe(all income levels) in 2008 to that in 2010?
Your answer should be very brief. 0.93. What is the ratio of the Number of passengers carried of Slovak Republic in 2008 to that in 2010?
Your answer should be compact. 35.94. What is the ratio of the Number of passengers carried of Europe(all income levels) in 2009 to that in 2010?
Offer a very short reply. 0.92. What is the ratio of the Number of passengers carried in Bosnia and Herzegovina in 2009 to that in 2010?
Your answer should be very brief. 1.42. What is the ratio of the Number of passengers carried of Slovak Republic in 2009 to that in 2010?
Give a very brief answer. 45.97. What is the difference between the highest and the second highest Number of passengers carried in Europe(all income levels)?
Your answer should be compact. 4.82e+07. What is the difference between the highest and the second highest Number of passengers carried of Bosnia and Herzegovina?
Offer a very short reply. 7113. What is the difference between the highest and the second highest Number of passengers carried in Slovak Republic?
Your answer should be very brief. 7.50e+05. What is the difference between the highest and the lowest Number of passengers carried in Europe(all income levels)?
Keep it short and to the point. 2.73e+08. What is the difference between the highest and the lowest Number of passengers carried of Bosnia and Herzegovina?
Offer a very short reply. 2.37e+04. What is the difference between the highest and the lowest Number of passengers carried of Slovak Republic?
Provide a short and direct response. 3.40e+06. 